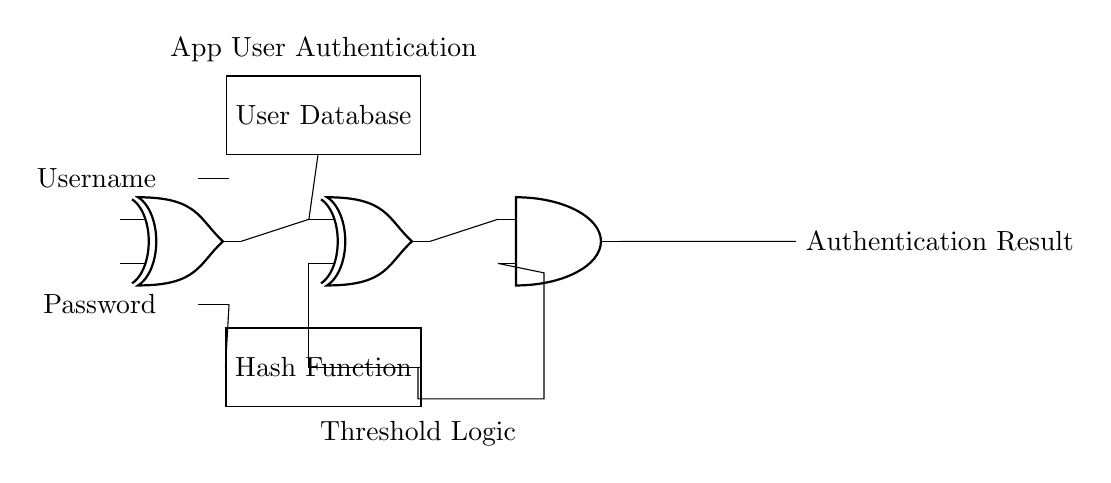What is the main function of the XOR gates in this circuit? The XOR gates are used to compare the input values (username and password) for authentication. An XOR gate outputs true only when the inputs differ and helps in verifying the uniqueness of user credentials.
Answer: Comparisons What is the role of the AND gate in the circuit? The AND gate combines the outputs of the XOR gates and the hash function to determine the final authentication result. It checks that both conditions (username/password correctness and hashed input) are satisfied before issuing a true output.
Answer: Final authentication What type of component is represented by the rectangle labeled "User Database"? The rectangle labeled "User Database" represents a memory component that stores valid user credentials. This information is used by the circuit to validate incoming user input during the authentication process.
Answer: Memory component What does the output of the circuit represent? The output of the circuit indicates whether the user authentication has been successful or not, determining the access level to the application based on the provided credentials.
Answer: Authentication result Which components are used for hashing in this circuit? The component used for hashing in this circuit is the "Hash Function" rectangle, which processes the password to ensure that it matches the secured version stored in the user database during authentication checks.
Answer: Hash Function How many inputs does the AND gate receive in this circuit? The AND gate receives two inputs: one from the output of the second XOR gate and the other from the threshold logic output. The gate ensures both input conditions must be satisfied for authentication to be considered successful.
Answer: Two inputs 